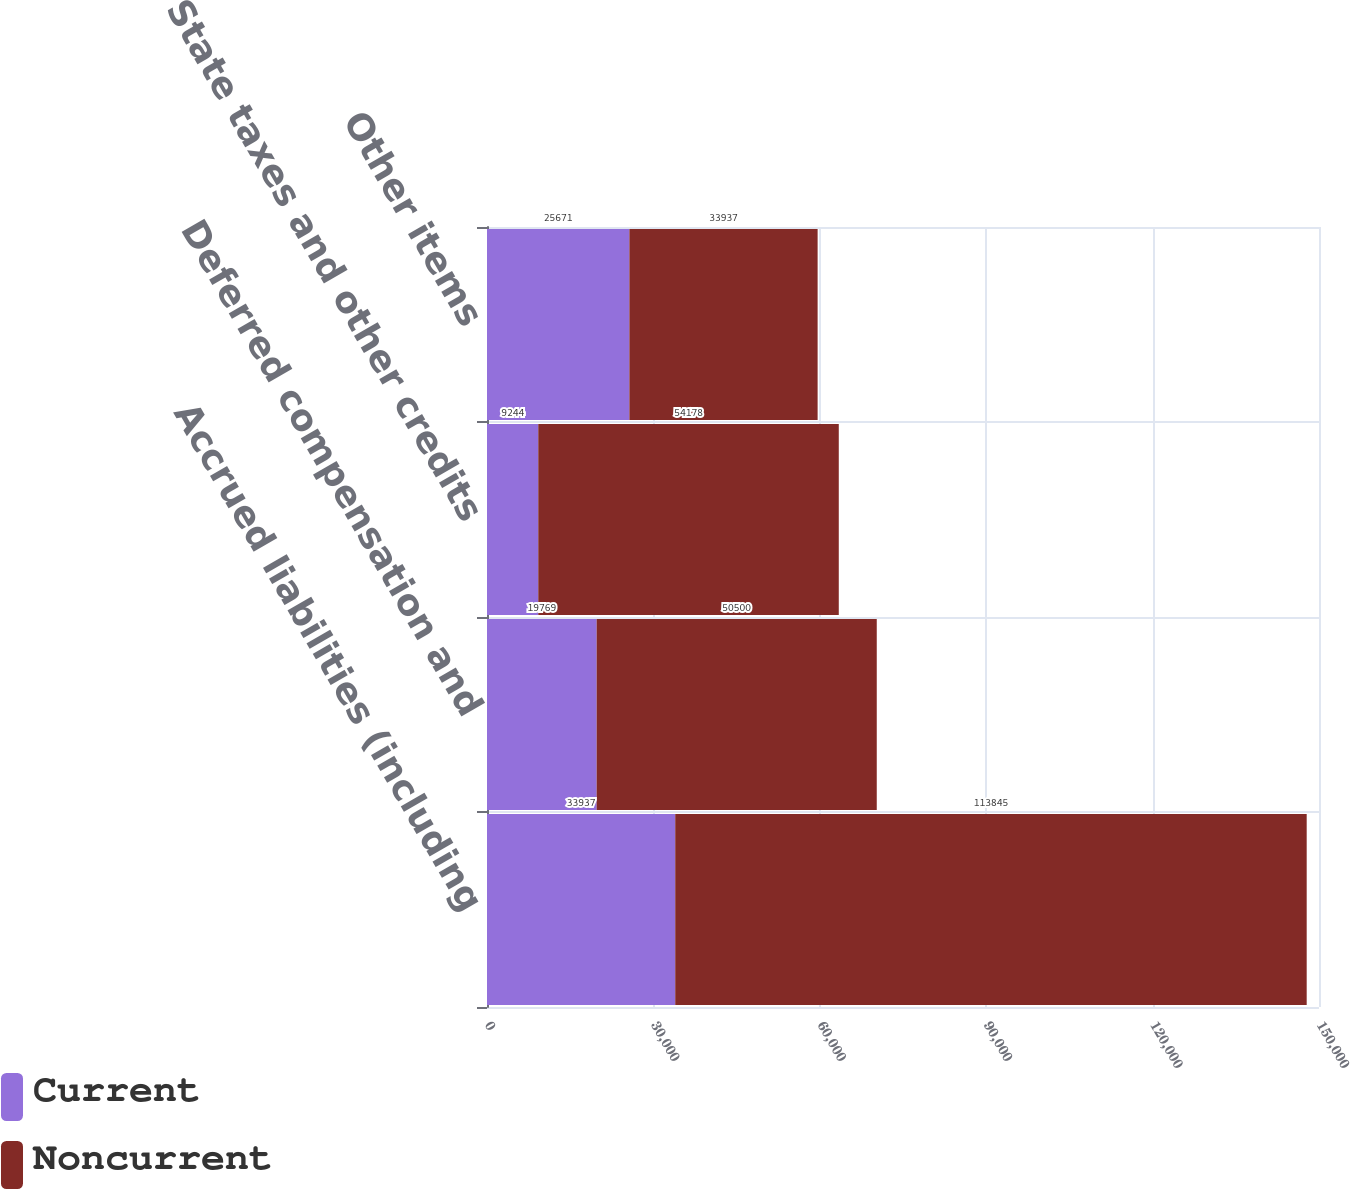Convert chart. <chart><loc_0><loc_0><loc_500><loc_500><stacked_bar_chart><ecel><fcel>Accrued liabilities (including<fcel>Deferred compensation and<fcel>State taxes and other credits<fcel>Other items<nl><fcel>Current<fcel>33937<fcel>19769<fcel>9244<fcel>25671<nl><fcel>Noncurrent<fcel>113845<fcel>50500<fcel>54178<fcel>33937<nl></chart> 